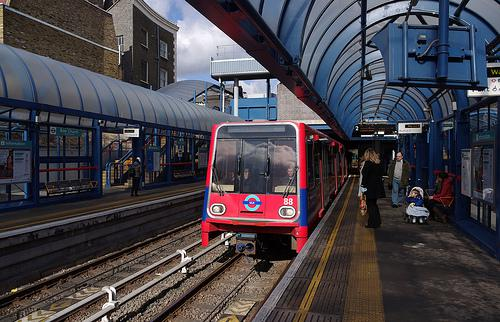Question: where was the picture taken?
Choices:
A. Metro station.
B. Bus station.
C. Train station.
D. Airport.
Answer with the letter. Answer: C Question: who is standing on the platform?
Choices:
A. Man.
B. Women.
C. Girl.
D. People.
Answer with the letter. Answer: D Question: what color is the train?
Choices:
A. Red, blue.
B. White.
C. Green.
D. Purple.
Answer with the letter. Answer: A Question: what color is the sky?
Choices:
A. Blue, and white.
B. Grey.
C. Black.
D. Yellow.
Answer with the letter. Answer: A Question: what is the train moving on?
Choices:
A. Tracks.
B. Rails.
C. Pavement.
D. Ground.
Answer with the letter. Answer: A 